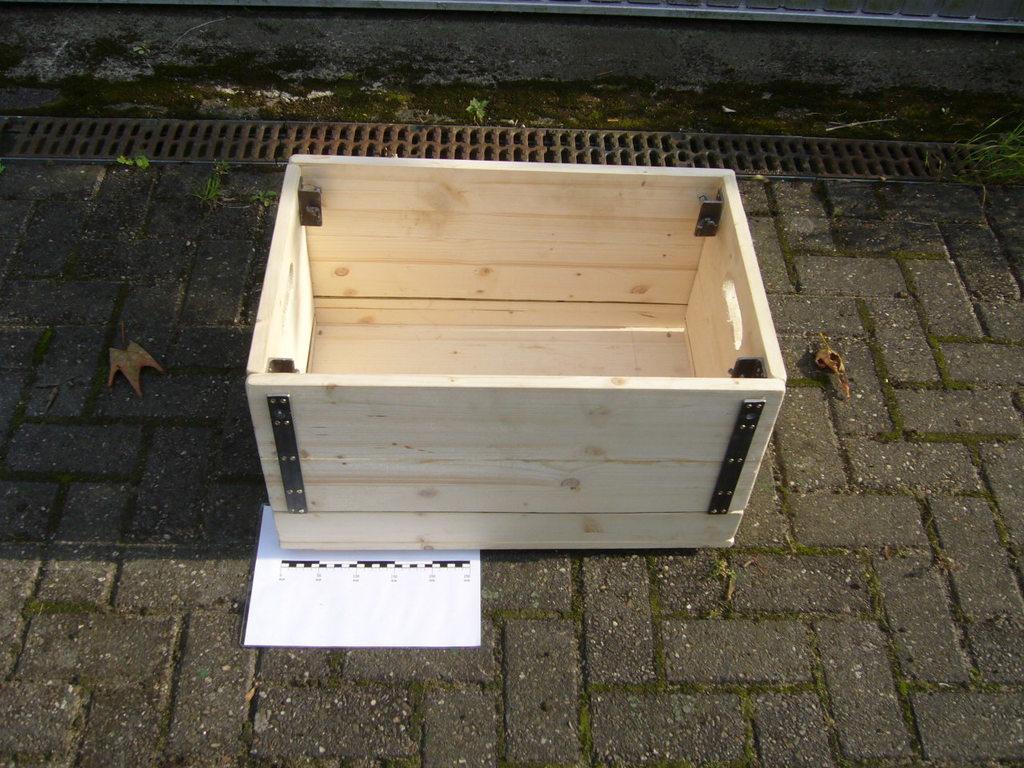Describe this image in one or two sentences. In the image there is a wooden box on the side of the road. 